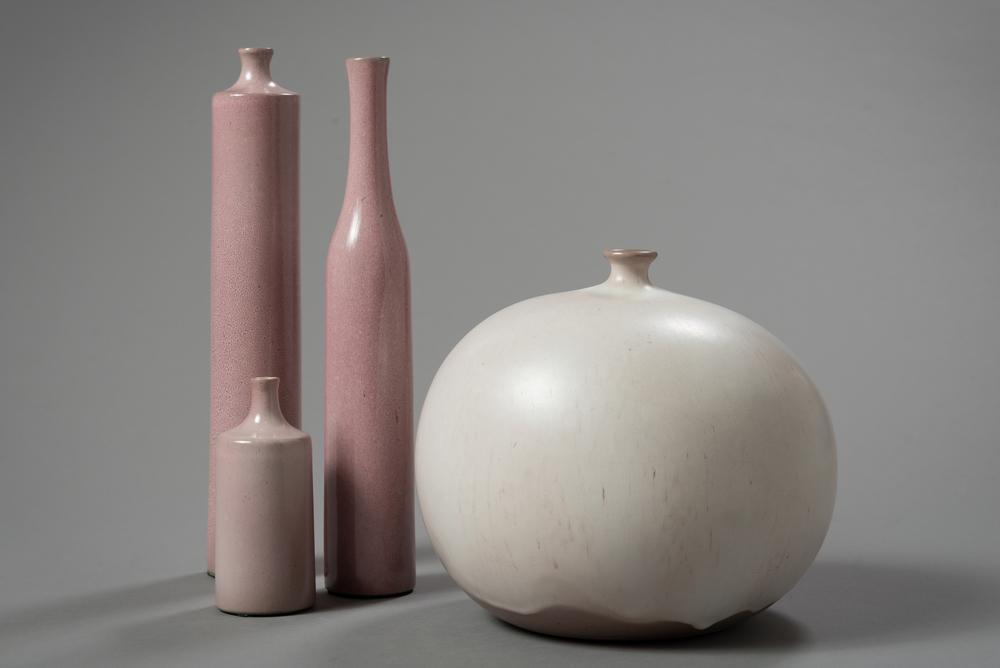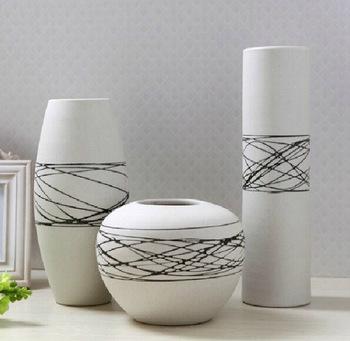The first image is the image on the left, the second image is the image on the right. Examine the images to the left and right. Is the description "There are at most six vases." accurate? Answer yes or no. No. 